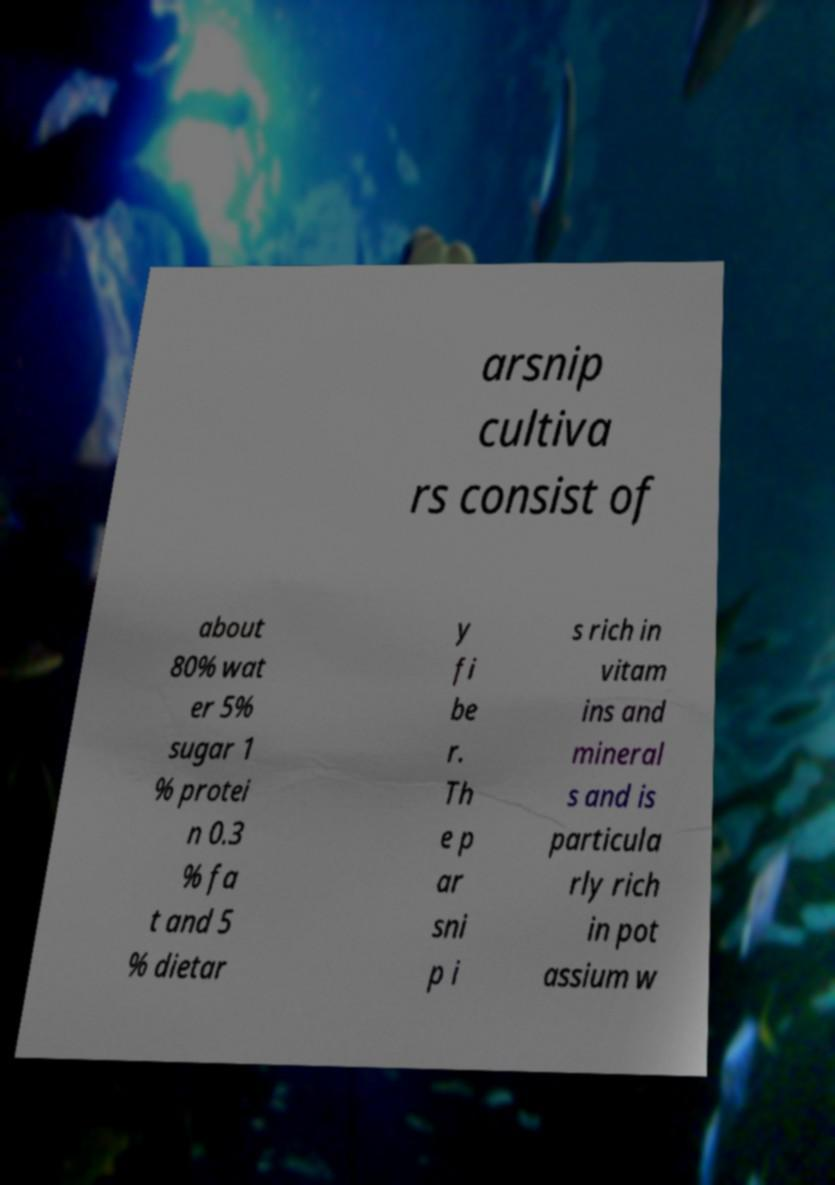Please identify and transcribe the text found in this image. arsnip cultiva rs consist of about 80% wat er 5% sugar 1 % protei n 0.3 % fa t and 5 % dietar y fi be r. Th e p ar sni p i s rich in vitam ins and mineral s and is particula rly rich in pot assium w 